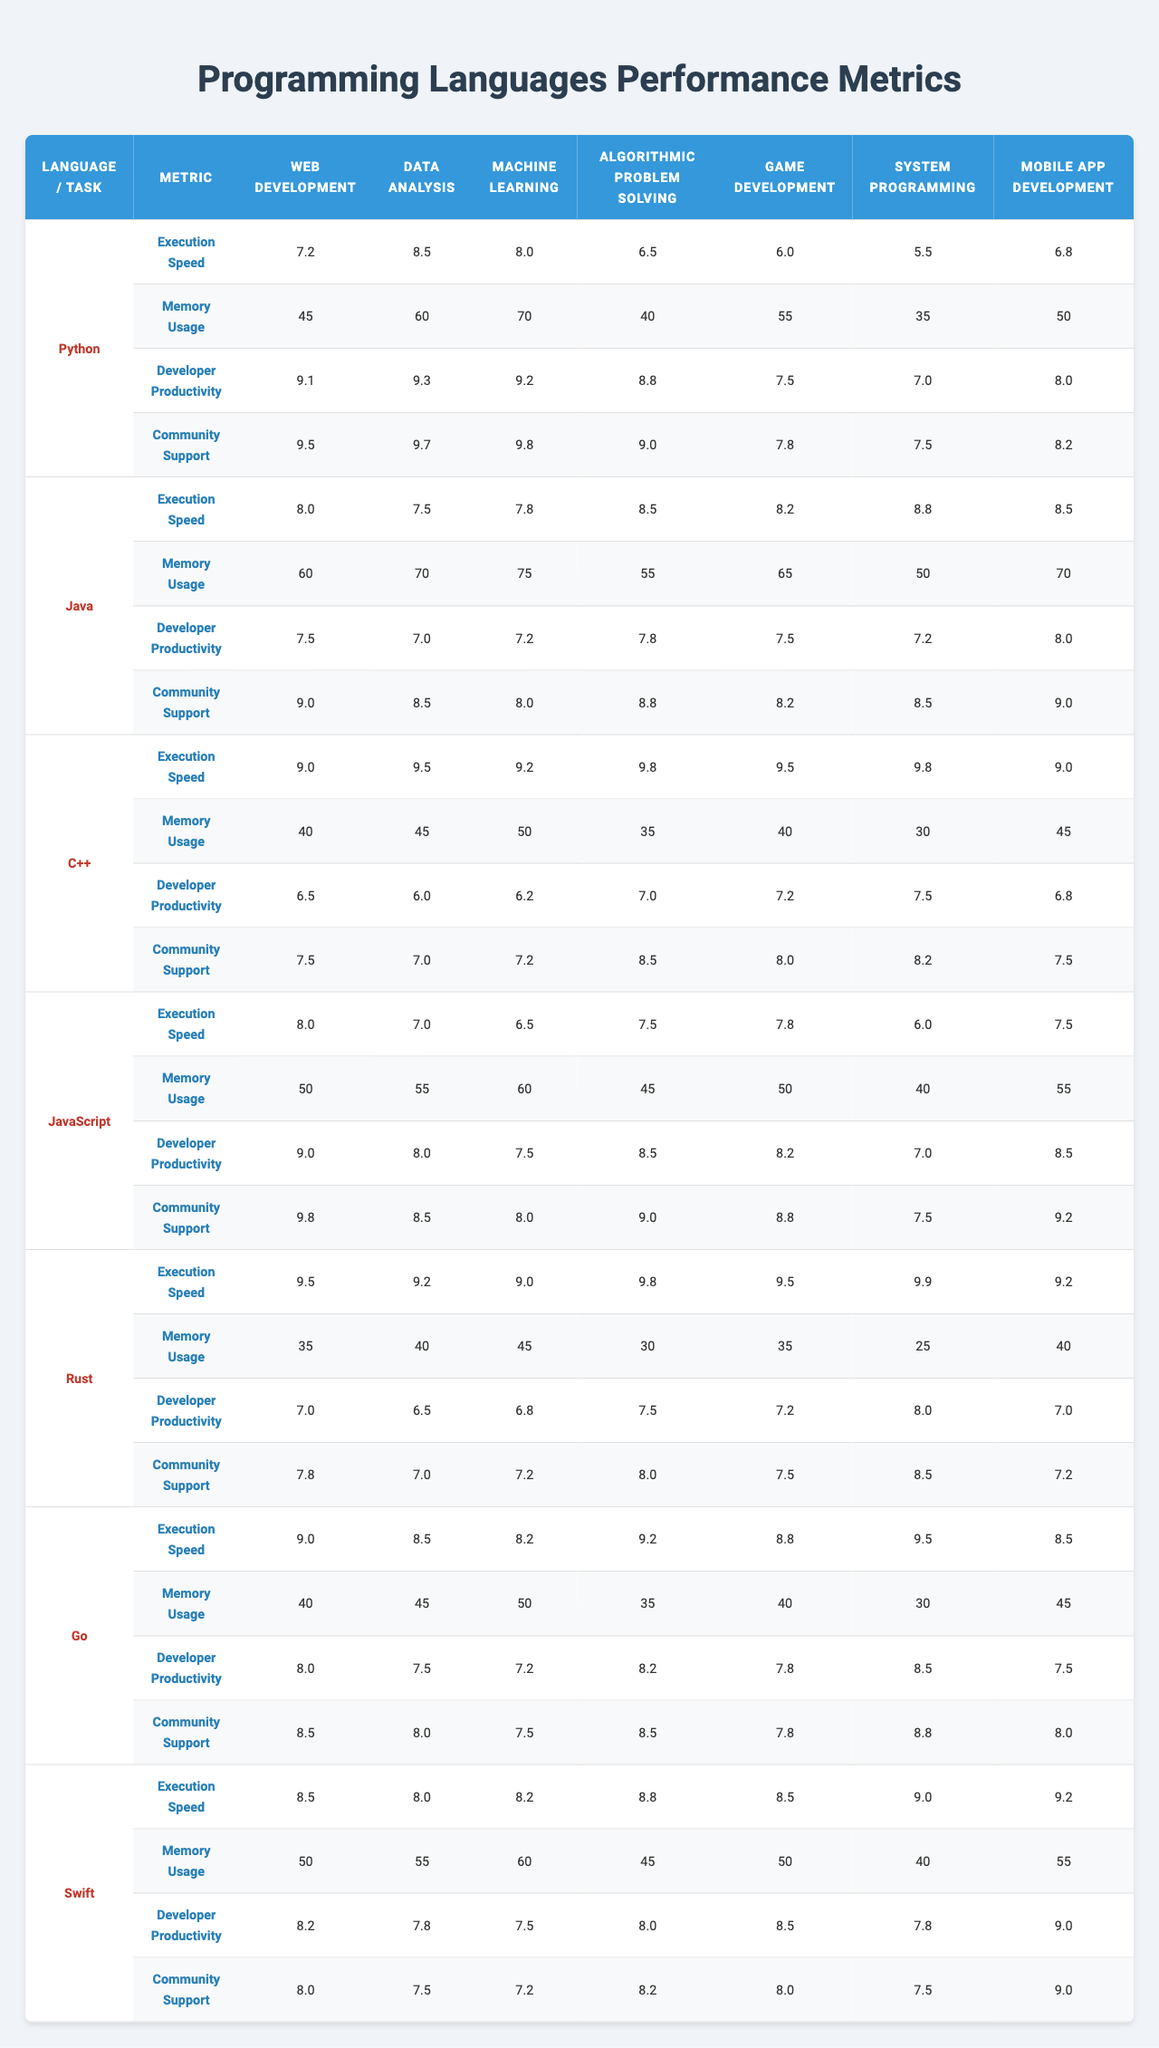What is the execution speed of Python in Machine Learning? The table lists Python's execution speed for Machine Learning as 8.0.
Answer: 8.0 Which programming language has the highest community support for Data Analysis? Looking at the Data Analysis section, Python has the highest community support score of 9.7.
Answer: Python What is the difference in execution speed between C++ and Rust for Game Development? C++ has an execution speed of 9.5 and Rust has 9.5 for Game Development. The difference is 9.5 - 9.5 = 0.
Answer: 0 True or False: Go has better memory usage performance than Python for Web Development. For Web Development, Go's memory usage is 40 while Python's is 45. Therefore, False.
Answer: False Which programming language shows the least developer productivity in System Programming? In the System Programming section, C++ shows a developer productivity score of 7.5, which is the lowest compared to others.
Answer: C++ What is the average execution speed across all computing tasks for Java? Java has different execution speeds for each task. Adding them gives (8.0 + 7.5 + 7.8 + 8.5 + 8.2 + 8.8 + 8.5) = 57.3. Dividing by 7 tasks gives an average of 57.3/7 = 8.19.
Answer: 8.19 Which language performs the best in Algorithmic Problem Solving and what is the score? The table shows that C++ has the highest execution speed in Algorithmic Problem Solving at 9.8.
Answer: C++ Does Swift perform better than JavaScript in Mobile App Development for developer productivity? Swift has a developer productivity score of 9.0, whereas JavaScript has 8.5 for Mobile App Development. Therefore, True.
Answer: True What is the sum of the community support scores for all programming languages in Game Development? The community support scores are Python (7.8), Java (8.2), C++ (8.0), JavaScript (8.8), Rust (7.5), Go (7.8), Swift (8.0). Adding them yields 7.8 + 8.2 + 8.0 + 8.8 + 7.5 + 7.8 + 8.0 = 57.1.
Answer: 57.1 Which programming language has the highest memory usage in Machine Learning? The memory usage for Machine Learning shows Python with 70, Java with 75, C++ with 50, JavaScript with 60, Rust with 45, Go with 50, and Swift with 60. Hence, Java has the highest memory usage at 75.
Answer: Java 